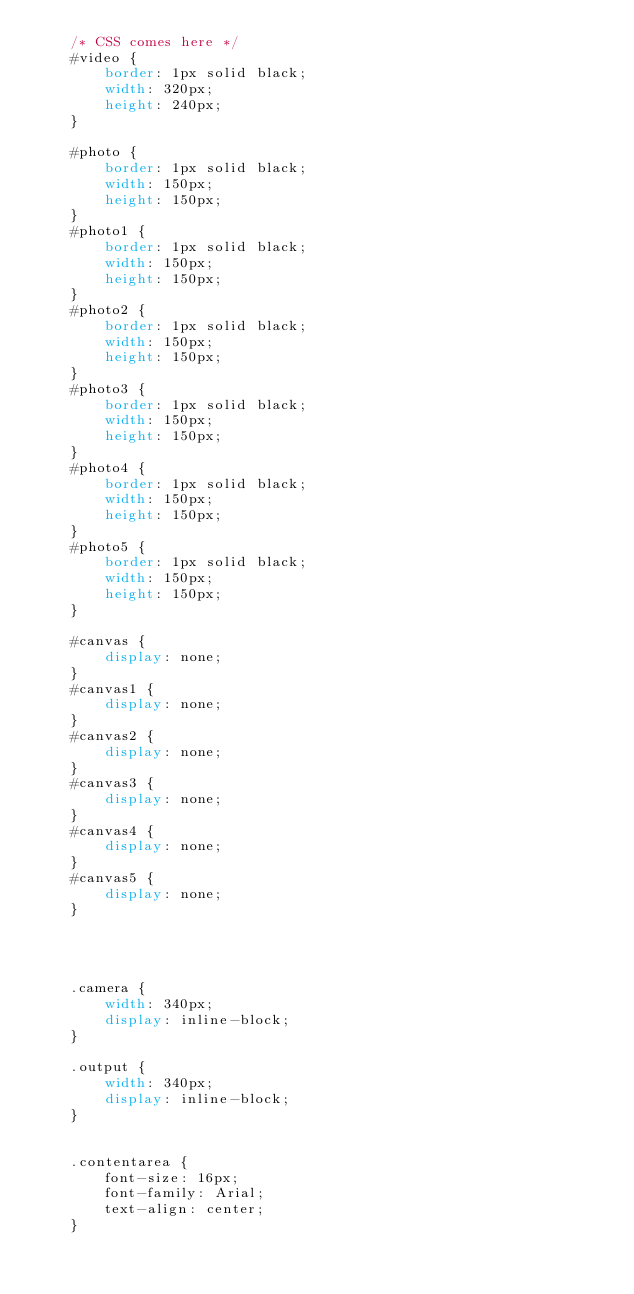Convert code to text. <code><loc_0><loc_0><loc_500><loc_500><_CSS_>    /* CSS comes here */
    #video {
        border: 1px solid black;
        width: 320px;
        height: 240px;
    }

    #photo {
        border: 1px solid black;
        width: 150px;
        height: 150px;
    }
    #photo1 {
        border: 1px solid black;
        width: 150px;
        height: 150px;
    }
    #photo2 {
        border: 1px solid black;
        width: 150px;
        height: 150px;
    }
    #photo3 {
        border: 1px solid black;
        width: 150px;
        height: 150px;
    }
    #photo4 {
        border: 1px solid black;
        width: 150px;
        height: 150px;
    }
    #photo5 {
        border: 1px solid black;
        width: 150px;
        height: 150px;
    }

    #canvas {
        display: none;
    }
    #canvas1 {
        display: none;
    }
    #canvas2 {
        display: none;
    }
    #canvas3 {
        display: none;
    }
    #canvas4 {
        display: none;
    }
    #canvas5 {
        display: none;
    }




    .camera {
        width: 340px;
        display: inline-block;
    }

    .output {
        width: 340px;
        display: inline-block;
    }


    .contentarea {
        font-size: 16px;
        font-family: Arial;
        text-align: center;
    }
</code> 